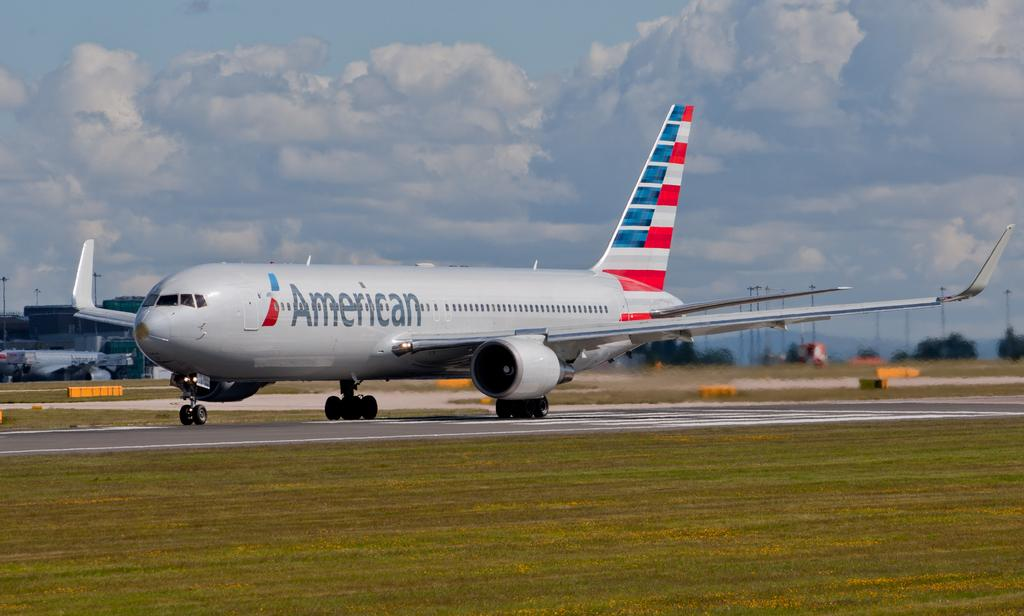<image>
Present a compact description of the photo's key features. an American Airlines jet just landing on a runway 